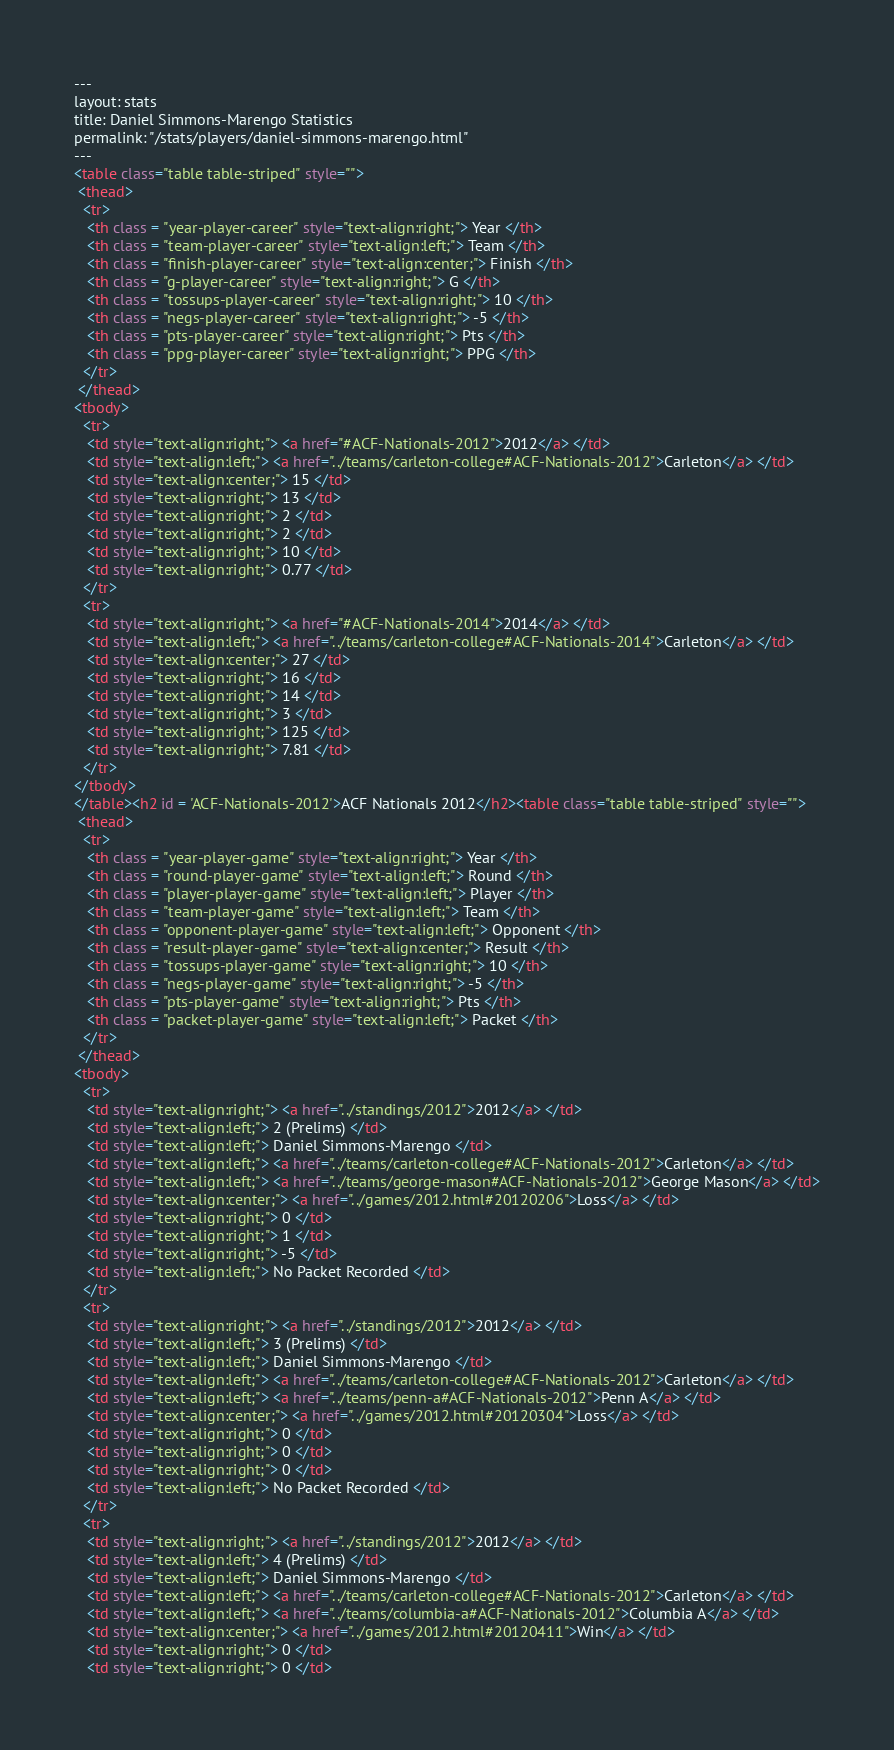Convert code to text. <code><loc_0><loc_0><loc_500><loc_500><_HTML_>---
layout: stats
title: Daniel Simmons-Marengo Statistics
permalink: "/stats/players/daniel-simmons-marengo.html"
---
<table class="table table-striped" style="">
 <thead>
  <tr>
   <th class = "year-player-career" style="text-align:right;"> Year </th>
   <th class = "team-player-career" style="text-align:left;"> Team </th>
   <th class = "finish-player-career" style="text-align:center;"> Finish </th>
   <th class = "g-player-career" style="text-align:right;"> G </th>
   <th class = "tossups-player-career" style="text-align:right;"> 10 </th>
   <th class = "negs-player-career" style="text-align:right;"> -5 </th>
   <th class = "pts-player-career" style="text-align:right;"> Pts </th>
   <th class = "ppg-player-career" style="text-align:right;"> PPG </th>
  </tr>
 </thead>
<tbody>
  <tr>
   <td style="text-align:right;"> <a href="#ACF-Nationals-2012">2012</a> </td>
   <td style="text-align:left;"> <a href="../teams/carleton-college#ACF-Nationals-2012">Carleton</a> </td>
   <td style="text-align:center;"> 15 </td>
   <td style="text-align:right;"> 13 </td>
   <td style="text-align:right;"> 2 </td>
   <td style="text-align:right;"> 2 </td>
   <td style="text-align:right;"> 10 </td>
   <td style="text-align:right;"> 0.77 </td>
  </tr>
  <tr>
   <td style="text-align:right;"> <a href="#ACF-Nationals-2014">2014</a> </td>
   <td style="text-align:left;"> <a href="../teams/carleton-college#ACF-Nationals-2014">Carleton</a> </td>
   <td style="text-align:center;"> 27 </td>
   <td style="text-align:right;"> 16 </td>
   <td style="text-align:right;"> 14 </td>
   <td style="text-align:right;"> 3 </td>
   <td style="text-align:right;"> 125 </td>
   <td style="text-align:right;"> 7.81 </td>
  </tr>
</tbody>
</table><h2 id = 'ACF-Nationals-2012'>ACF Nationals 2012</h2><table class="table table-striped" style="">
 <thead>
  <tr>
   <th class = "year-player-game" style="text-align:right;"> Year </th>
   <th class = "round-player-game" style="text-align:left;"> Round </th>
   <th class = "player-player-game" style="text-align:left;"> Player </th>
   <th class = "team-player-game" style="text-align:left;"> Team </th>
   <th class = "opponent-player-game" style="text-align:left;"> Opponent </th>
   <th class = "result-player-game" style="text-align:center;"> Result </th>
   <th class = "tossups-player-game" style="text-align:right;"> 10 </th>
   <th class = "negs-player-game" style="text-align:right;"> -5 </th>
   <th class = "pts-player-game" style="text-align:right;"> Pts </th>
   <th class = "packet-player-game" style="text-align:left;"> Packet </th>
  </tr>
 </thead>
<tbody>
  <tr>
   <td style="text-align:right;"> <a href="../standings/2012">2012</a> </td>
   <td style="text-align:left;"> 2 (Prelims) </td>
   <td style="text-align:left;"> Daniel Simmons-Marengo </td>
   <td style="text-align:left;"> <a href="../teams/carleton-college#ACF-Nationals-2012">Carleton</a> </td>
   <td style="text-align:left;"> <a href="../teams/george-mason#ACF-Nationals-2012">George Mason</a> </td>
   <td style="text-align:center;"> <a href="../games/2012.html#20120206">Loss</a> </td>
   <td style="text-align:right;"> 0 </td>
   <td style="text-align:right;"> 1 </td>
   <td style="text-align:right;"> -5 </td>
   <td style="text-align:left;"> No Packet Recorded </td>
  </tr>
  <tr>
   <td style="text-align:right;"> <a href="../standings/2012">2012</a> </td>
   <td style="text-align:left;"> 3 (Prelims) </td>
   <td style="text-align:left;"> Daniel Simmons-Marengo </td>
   <td style="text-align:left;"> <a href="../teams/carleton-college#ACF-Nationals-2012">Carleton</a> </td>
   <td style="text-align:left;"> <a href="../teams/penn-a#ACF-Nationals-2012">Penn A</a> </td>
   <td style="text-align:center;"> <a href="../games/2012.html#20120304">Loss</a> </td>
   <td style="text-align:right;"> 0 </td>
   <td style="text-align:right;"> 0 </td>
   <td style="text-align:right;"> 0 </td>
   <td style="text-align:left;"> No Packet Recorded </td>
  </tr>
  <tr>
   <td style="text-align:right;"> <a href="../standings/2012">2012</a> </td>
   <td style="text-align:left;"> 4 (Prelims) </td>
   <td style="text-align:left;"> Daniel Simmons-Marengo </td>
   <td style="text-align:left;"> <a href="../teams/carleton-college#ACF-Nationals-2012">Carleton</a> </td>
   <td style="text-align:left;"> <a href="../teams/columbia-a#ACF-Nationals-2012">Columbia A</a> </td>
   <td style="text-align:center;"> <a href="../games/2012.html#20120411">Win</a> </td>
   <td style="text-align:right;"> 0 </td>
   <td style="text-align:right;"> 0 </td></code> 